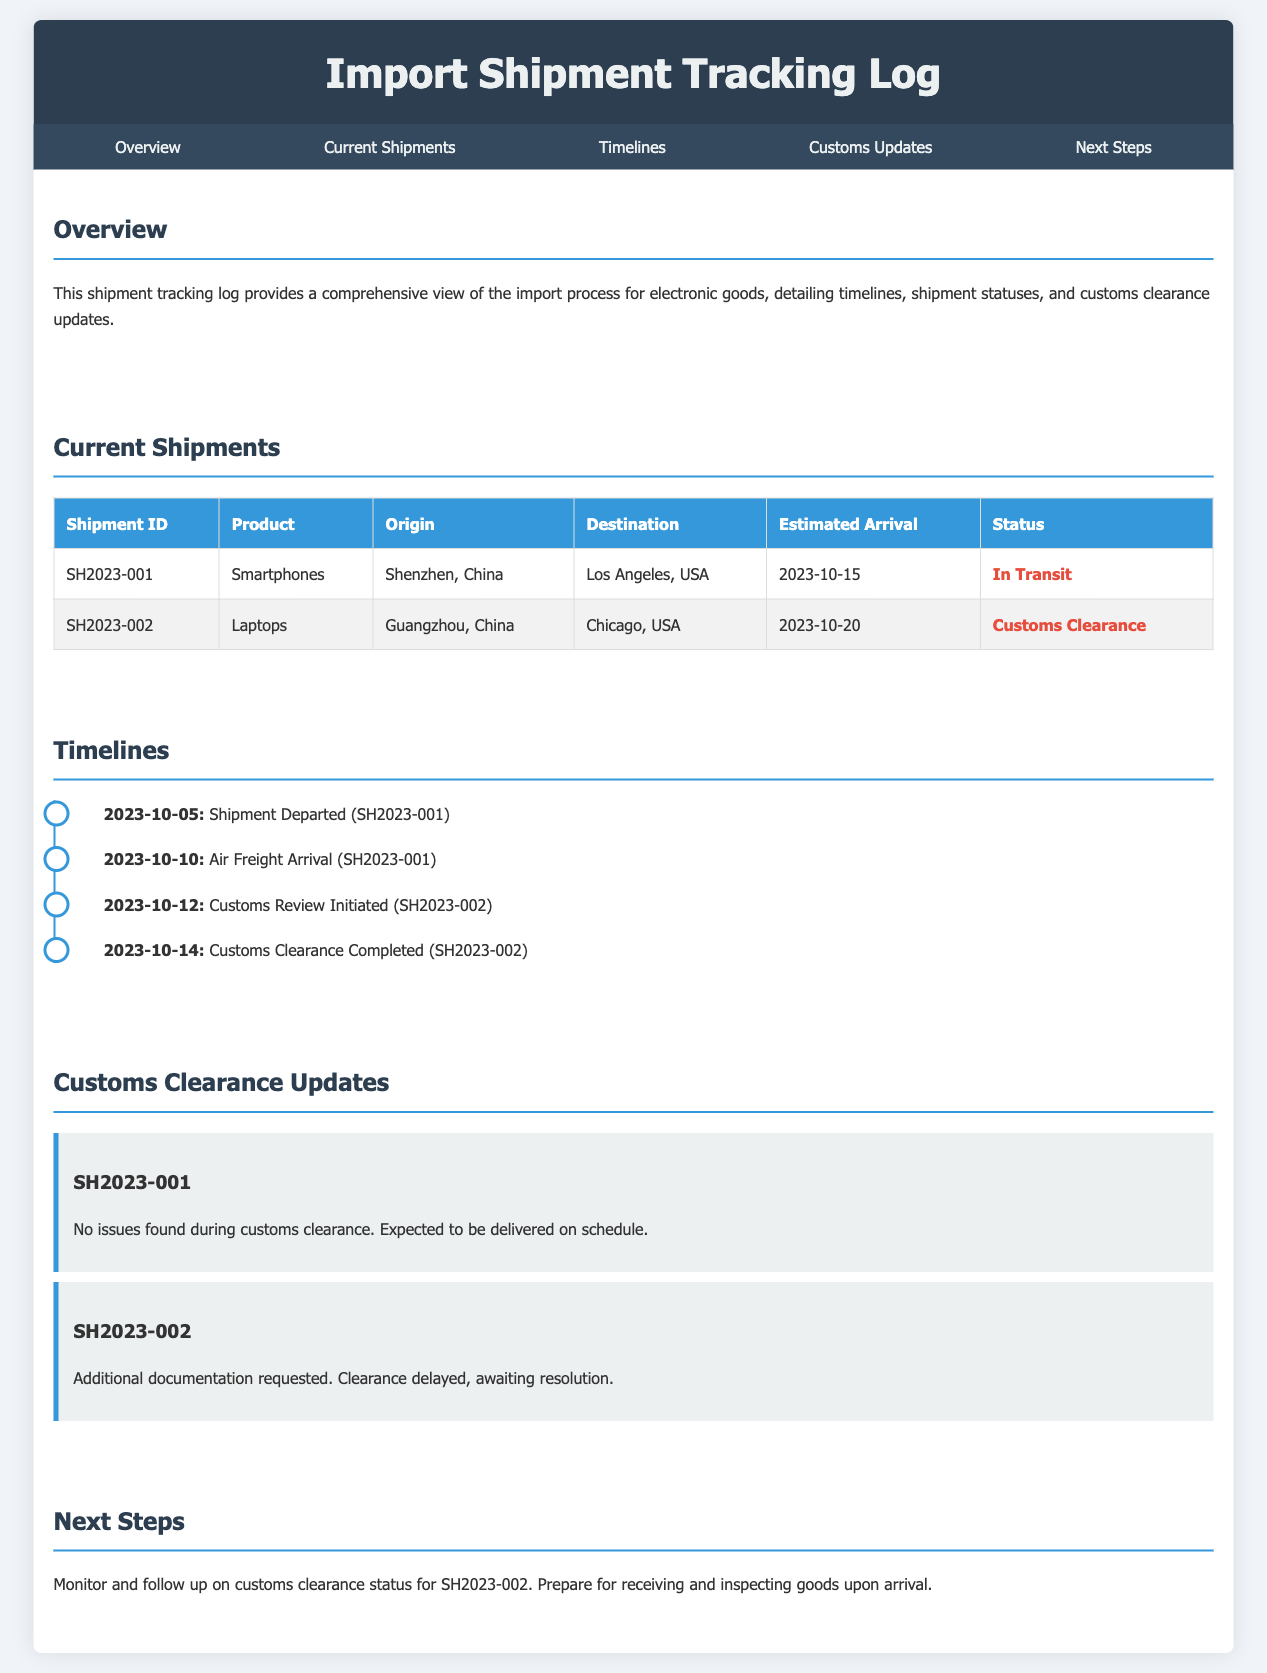what is the first shipment ID? The first shipment ID listed in the document is SH2023-001.
Answer: SH2023-001 what is the status of the laptops shipment? The status of the laptops shipment (SH2023-002) is indicated as Customs Clearance.
Answer: Customs Clearance what is the estimated arrival date for smartphones? The estimated arrival date for smartphones (SH2023-001) is 2023-10-15.
Answer: 2023-10-15 what did the customs update say for SH2023-002? The customs update for SH2023-002 notes that additional documentation was requested, causing a delay.
Answer: Additional documentation requested when was the shipment with ID SH2023-001 departed? The shipment with ID SH2023-001 departed on 2023-10-05.
Answer: 2023-10-05 how many shipments are currently listed in the document? There are two shipments currently listed in the document.
Answer: Two what action is recommended in the next steps section? The next steps section recommends monitoring and following up on customs clearance status for SH2023-002.
Answer: Monitor customs clearance status what was the last event listed in the timelines? The last event listed in the timelines is Customs Clearance Completed for SH2023-002.
Answer: Customs Clearance Completed what city is the origin for the laptops? The origin for the laptops (SH2023-002) is Guangzhou.
Answer: Guangzhou 